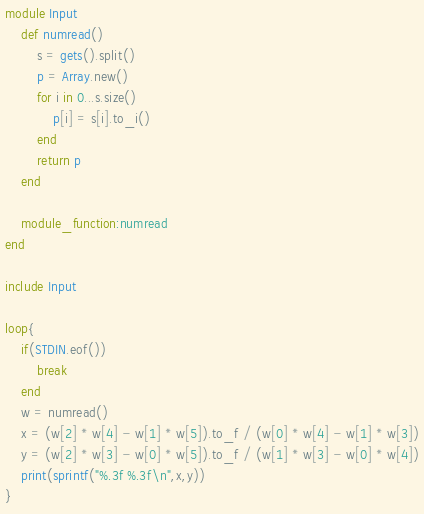Convert code to text. <code><loc_0><loc_0><loc_500><loc_500><_Ruby_>module Input
	def numread()
		s = gets().split()
		p = Array.new()
		for i in 0...s.size()
			p[i] = s[i].to_i()
		end
		return p
	end
	
	module_function:numread
end

include Input

loop{
	if(STDIN.eof())
		break
	end
	w = numread()
	x = (w[2] * w[4] - w[1] * w[5]).to_f / (w[0] * w[4] - w[1] * w[3])
	y = (w[2] * w[3] - w[0] * w[5]).to_f / (w[1] * w[3] - w[0] * w[4])
	print(sprintf("%.3f %.3f\n",x,y))
}</code> 